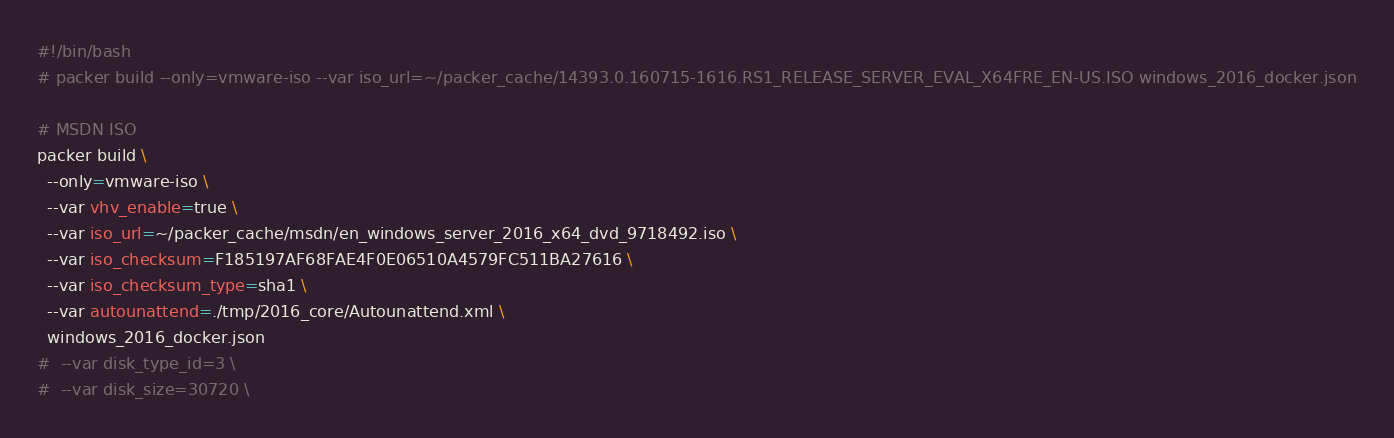<code> <loc_0><loc_0><loc_500><loc_500><_Bash_>#!/bin/bash
# packer build --only=vmware-iso --var iso_url=~/packer_cache/14393.0.160715-1616.RS1_RELEASE_SERVER_EVAL_X64FRE_EN-US.ISO windows_2016_docker.json

# MSDN ISO
packer build \
  --only=vmware-iso \
  --var vhv_enable=true \
  --var iso_url=~/packer_cache/msdn/en_windows_server_2016_x64_dvd_9718492.iso \
  --var iso_checksum=F185197AF68FAE4F0E06510A4579FC511BA27616 \
  --var iso_checksum_type=sha1 \
  --var autounattend=./tmp/2016_core/Autounattend.xml \
  windows_2016_docker.json
#  --var disk_type_id=3 \
#  --var disk_size=30720 \
</code> 